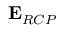<formula> <loc_0><loc_0><loc_500><loc_500>{ E } _ { R C P }</formula> 